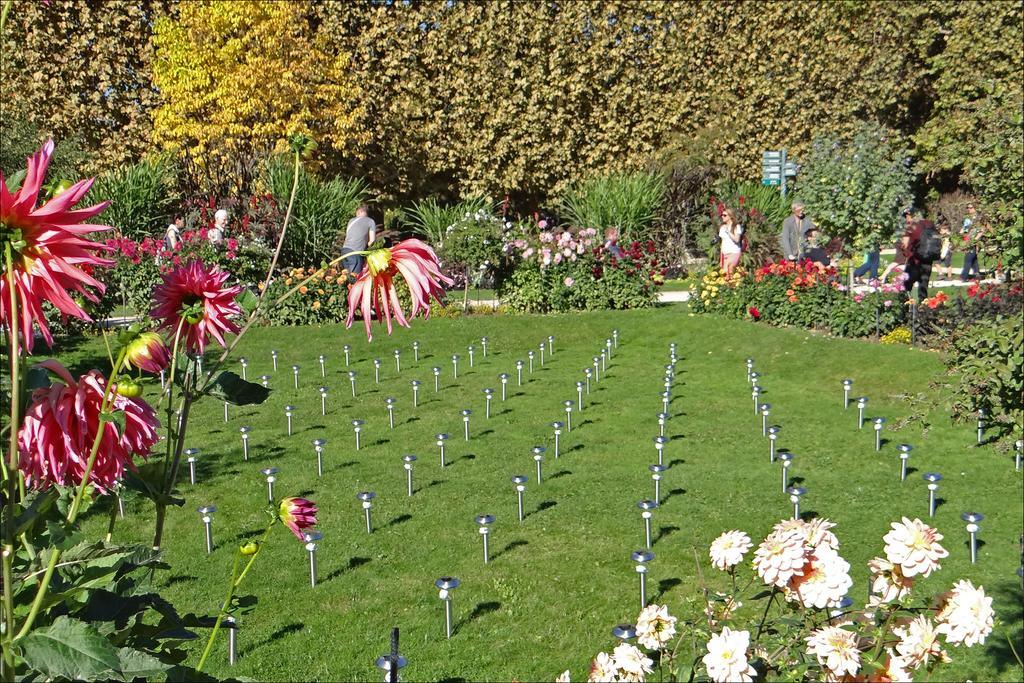What type of vegetation can be seen in the image? There are flowers, grass, and trees in the image. What structures are present in the image? There are poles and boards in the image. What is the group of people doing in the image? There is a group of people walking on the ground in the image. What type of brass instrument is being played by the group of people in the image? There is no brass instrument visible in the image; the group of people is simply walking on the ground. 